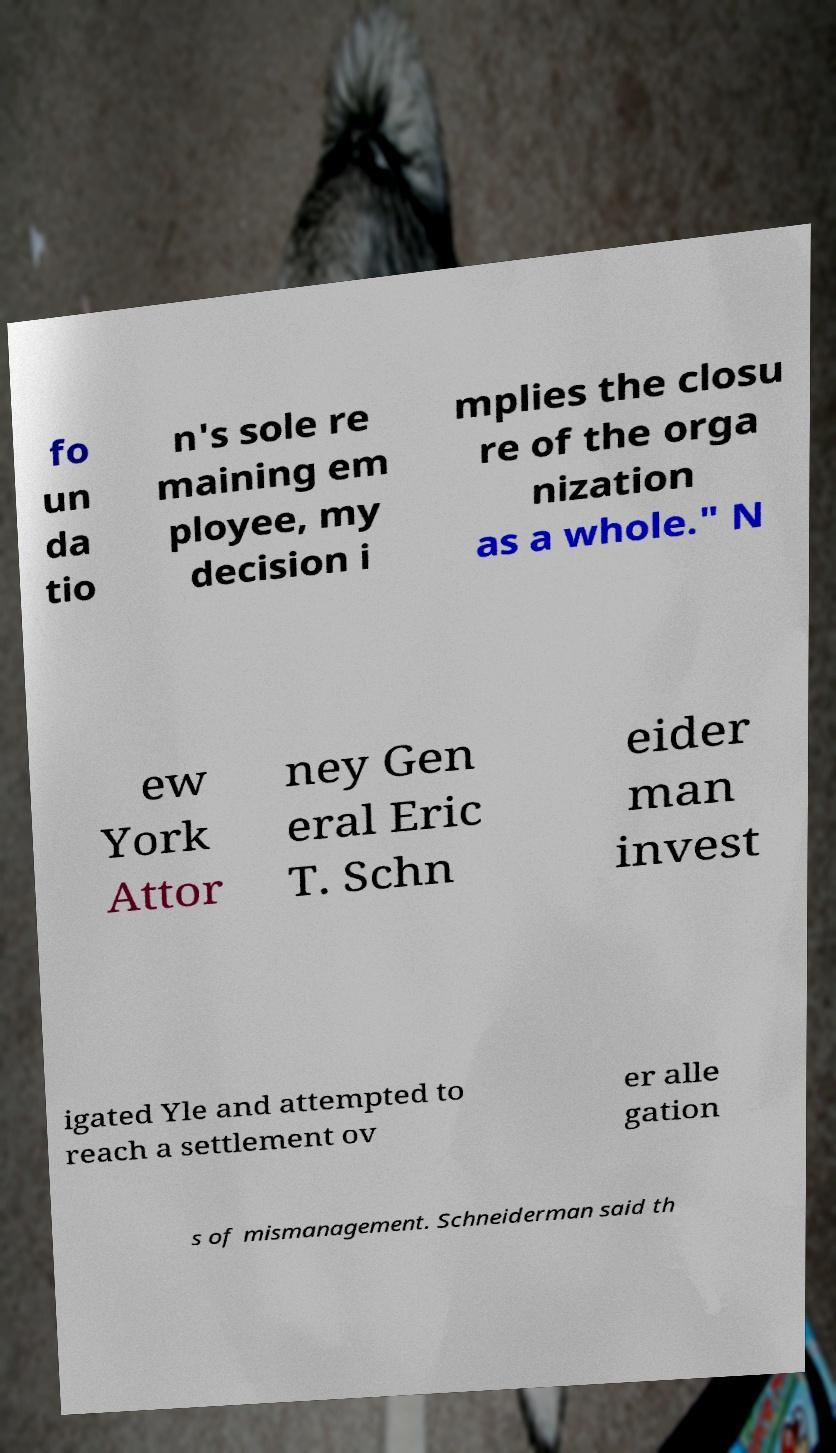There's text embedded in this image that I need extracted. Can you transcribe it verbatim? fo un da tio n's sole re maining em ployee, my decision i mplies the closu re of the orga nization as a whole." N ew York Attor ney Gen eral Eric T. Schn eider man invest igated Yle and attempted to reach a settlement ov er alle gation s of mismanagement. Schneiderman said th 